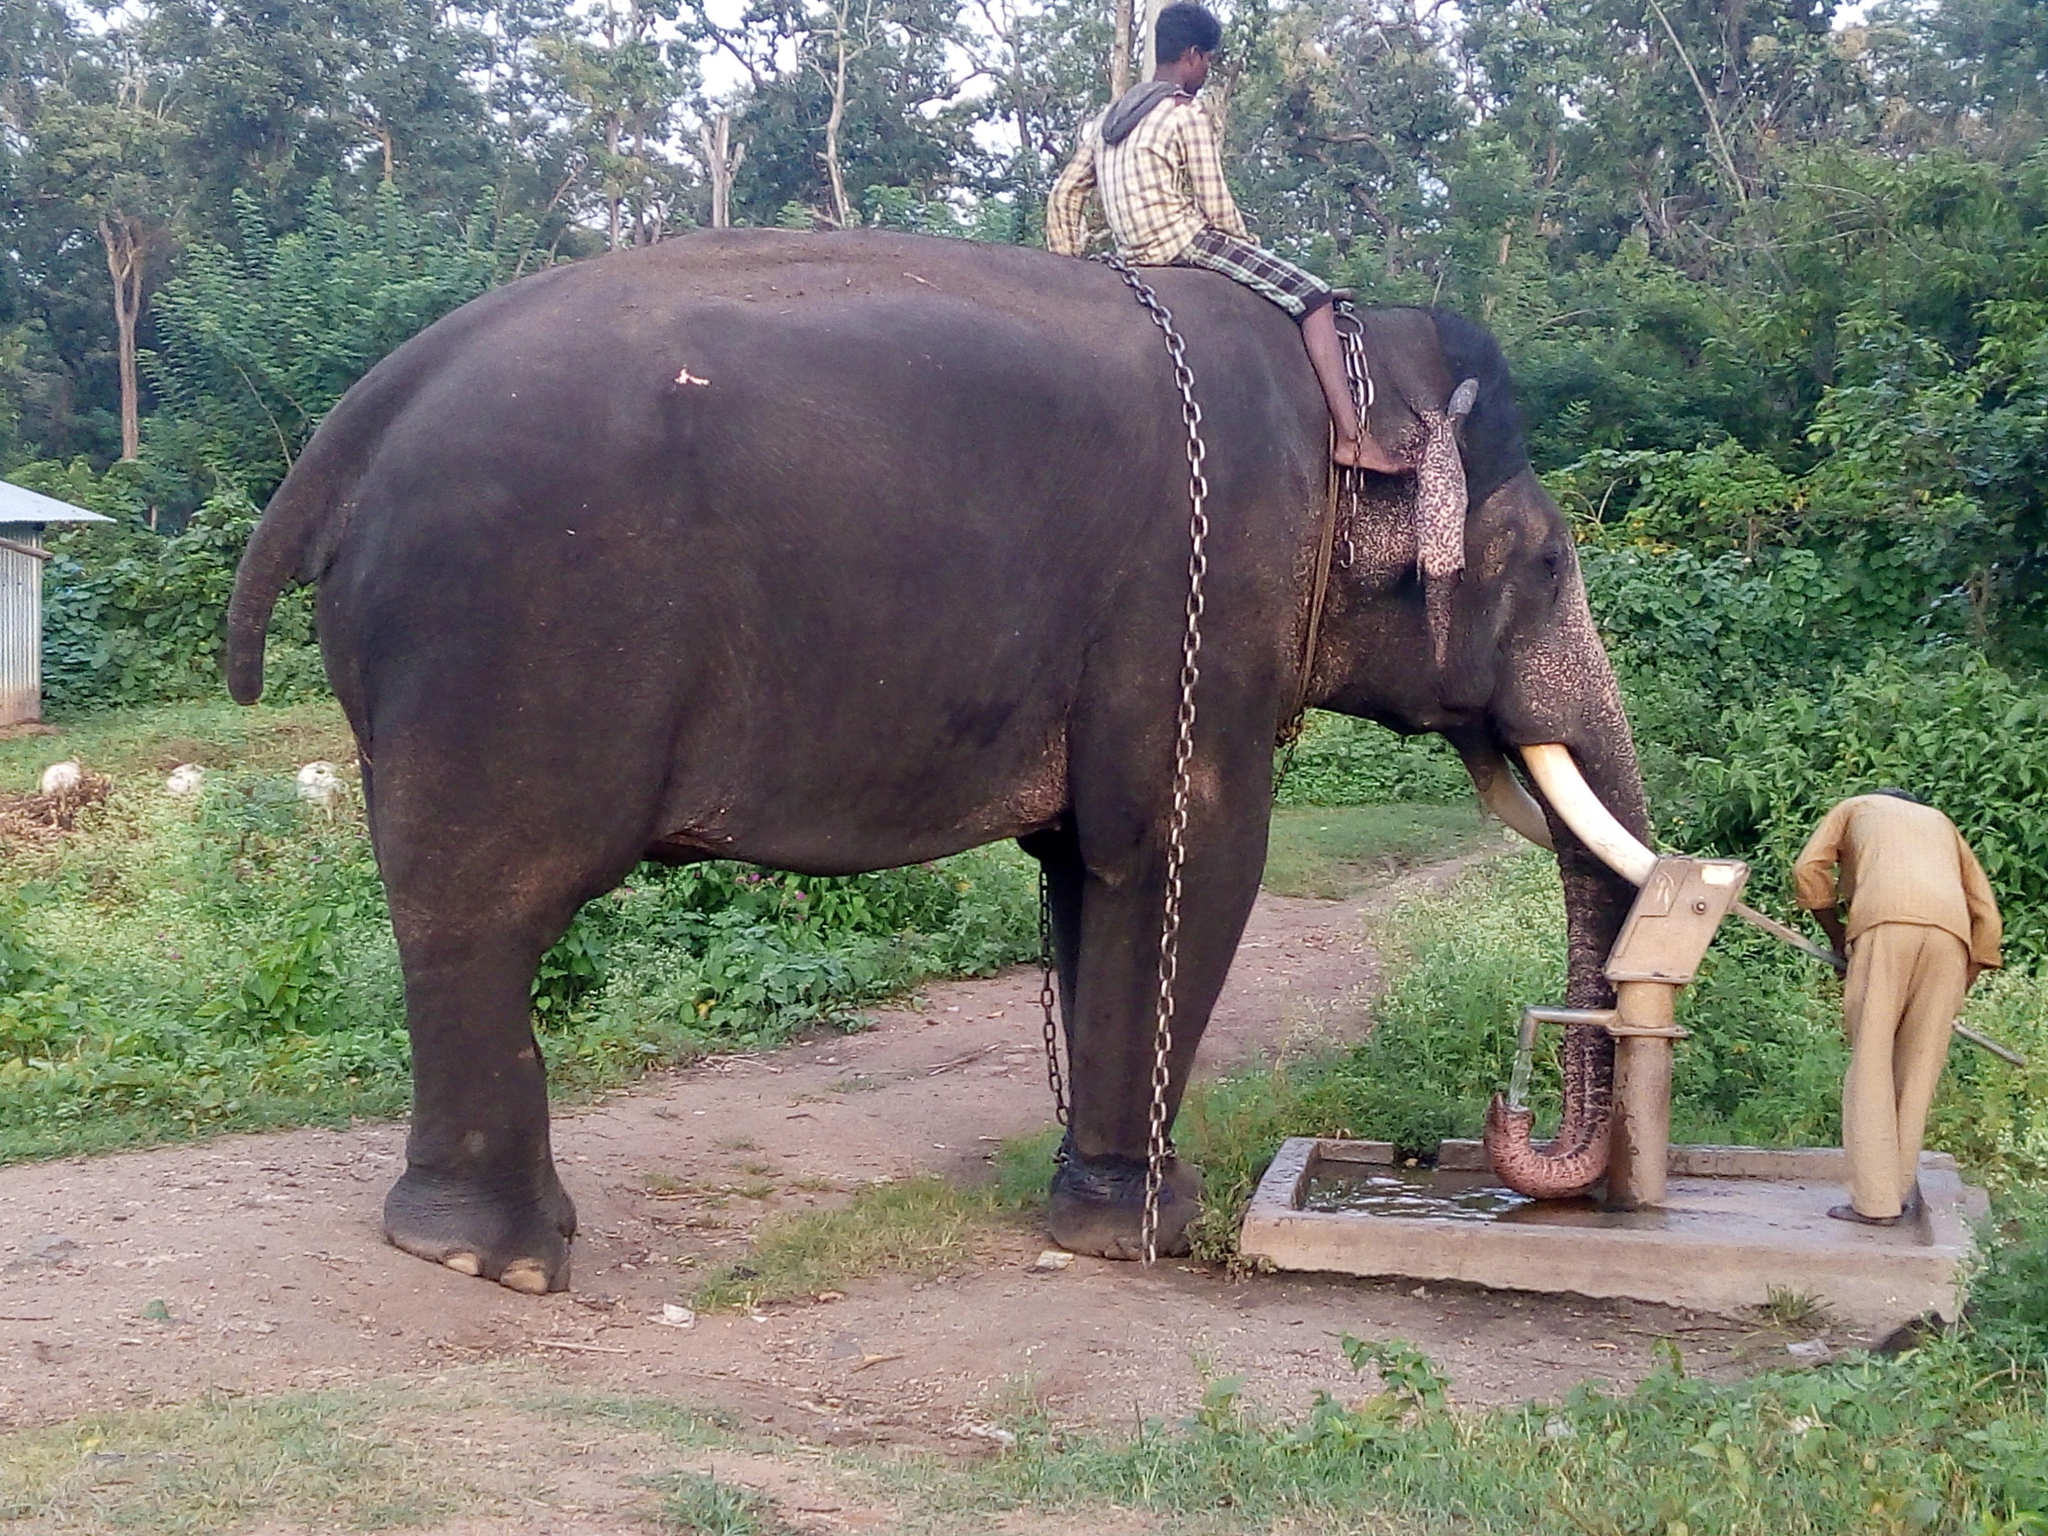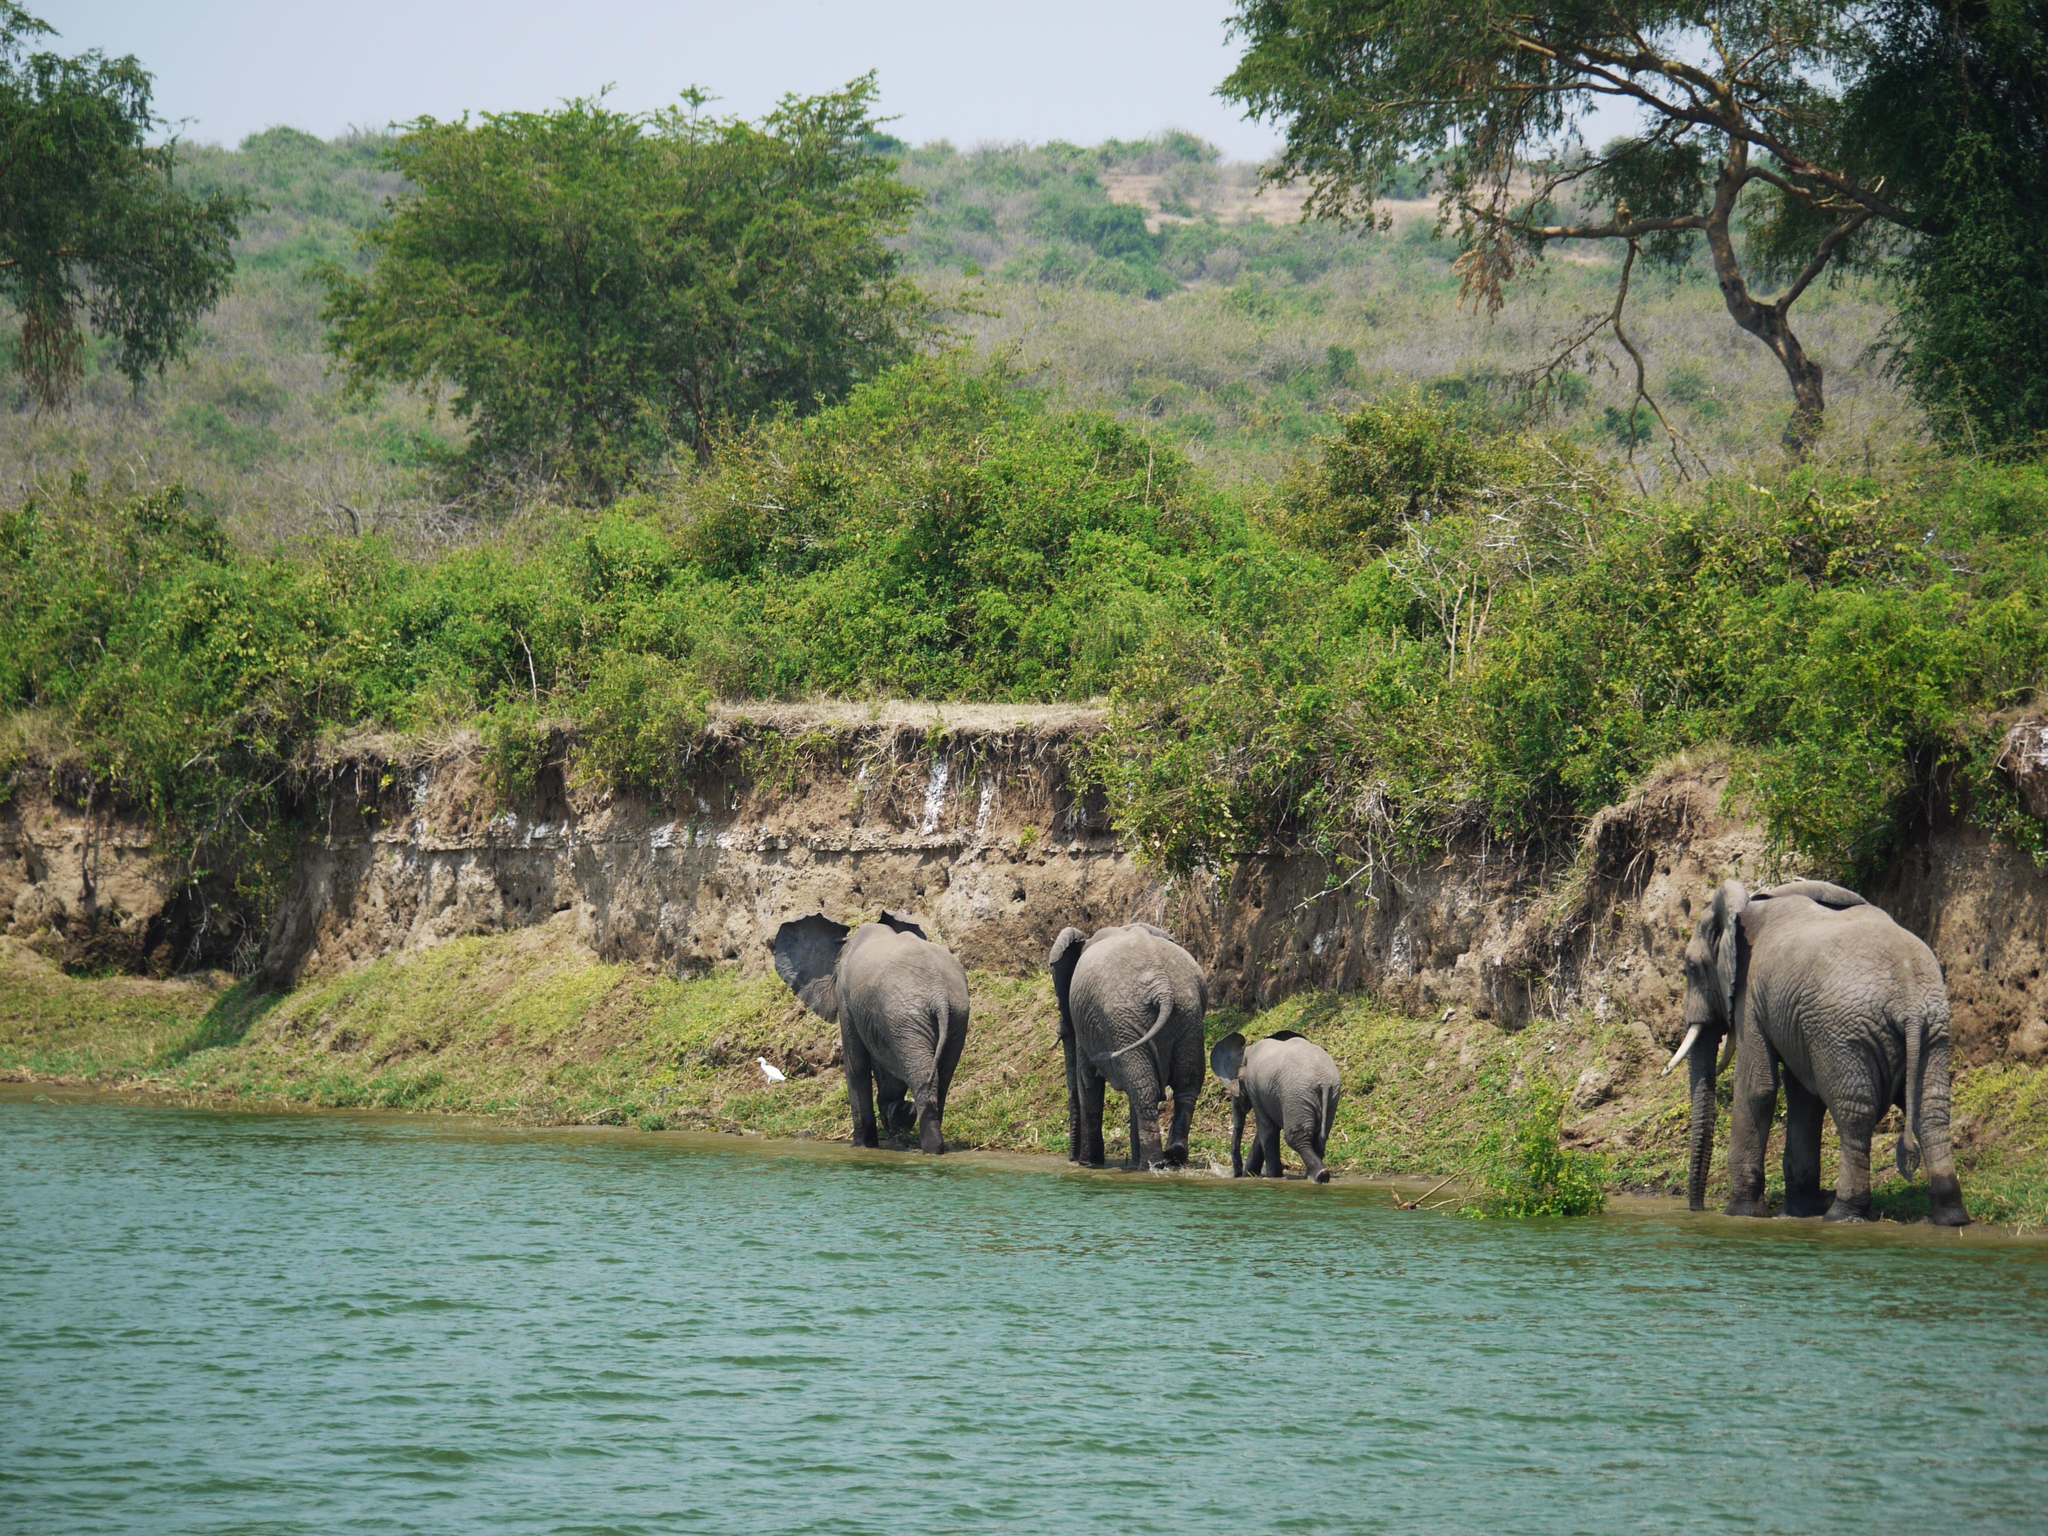The first image is the image on the left, the second image is the image on the right. Evaluate the accuracy of this statement regarding the images: "There are at least four elephants in the water.". Is it true? Answer yes or no. No. The first image is the image on the left, the second image is the image on the right. Analyze the images presented: Is the assertion "One of the images contains exactly four elephants." valid? Answer yes or no. Yes. 